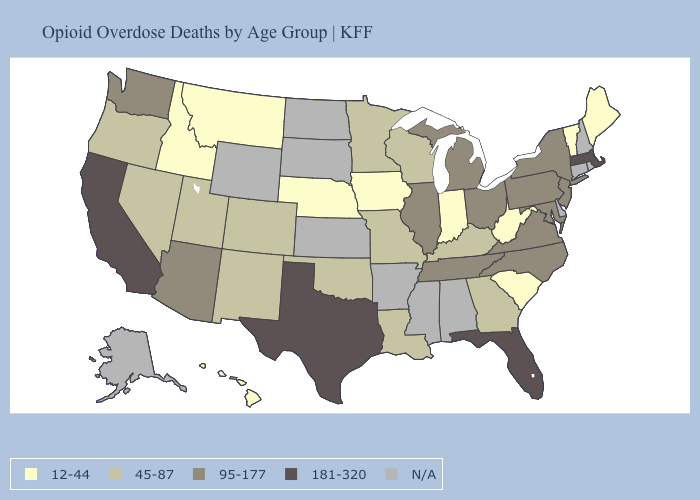Name the states that have a value in the range 45-87?
Keep it brief. Colorado, Georgia, Kentucky, Louisiana, Minnesota, Missouri, Nevada, New Mexico, Oklahoma, Oregon, Utah, Wisconsin. What is the value of Louisiana?
Concise answer only. 45-87. Name the states that have a value in the range N/A?
Keep it brief. Alabama, Alaska, Arkansas, Connecticut, Delaware, Kansas, Mississippi, New Hampshire, North Dakota, Rhode Island, South Dakota, Wyoming. Name the states that have a value in the range 45-87?
Write a very short answer. Colorado, Georgia, Kentucky, Louisiana, Minnesota, Missouri, Nevada, New Mexico, Oklahoma, Oregon, Utah, Wisconsin. What is the value of Kentucky?
Quick response, please. 45-87. What is the value of Nebraska?
Short answer required. 12-44. What is the lowest value in states that border New Jersey?
Give a very brief answer. 95-177. What is the value of Delaware?
Answer briefly. N/A. Name the states that have a value in the range 12-44?
Short answer required. Hawaii, Idaho, Indiana, Iowa, Maine, Montana, Nebraska, South Carolina, Vermont, West Virginia. Name the states that have a value in the range 95-177?
Be succinct. Arizona, Illinois, Maryland, Michigan, New Jersey, New York, North Carolina, Ohio, Pennsylvania, Tennessee, Virginia, Washington. What is the lowest value in the West?
Short answer required. 12-44. Name the states that have a value in the range N/A?
Short answer required. Alabama, Alaska, Arkansas, Connecticut, Delaware, Kansas, Mississippi, New Hampshire, North Dakota, Rhode Island, South Dakota, Wyoming. How many symbols are there in the legend?
Keep it brief. 5. 